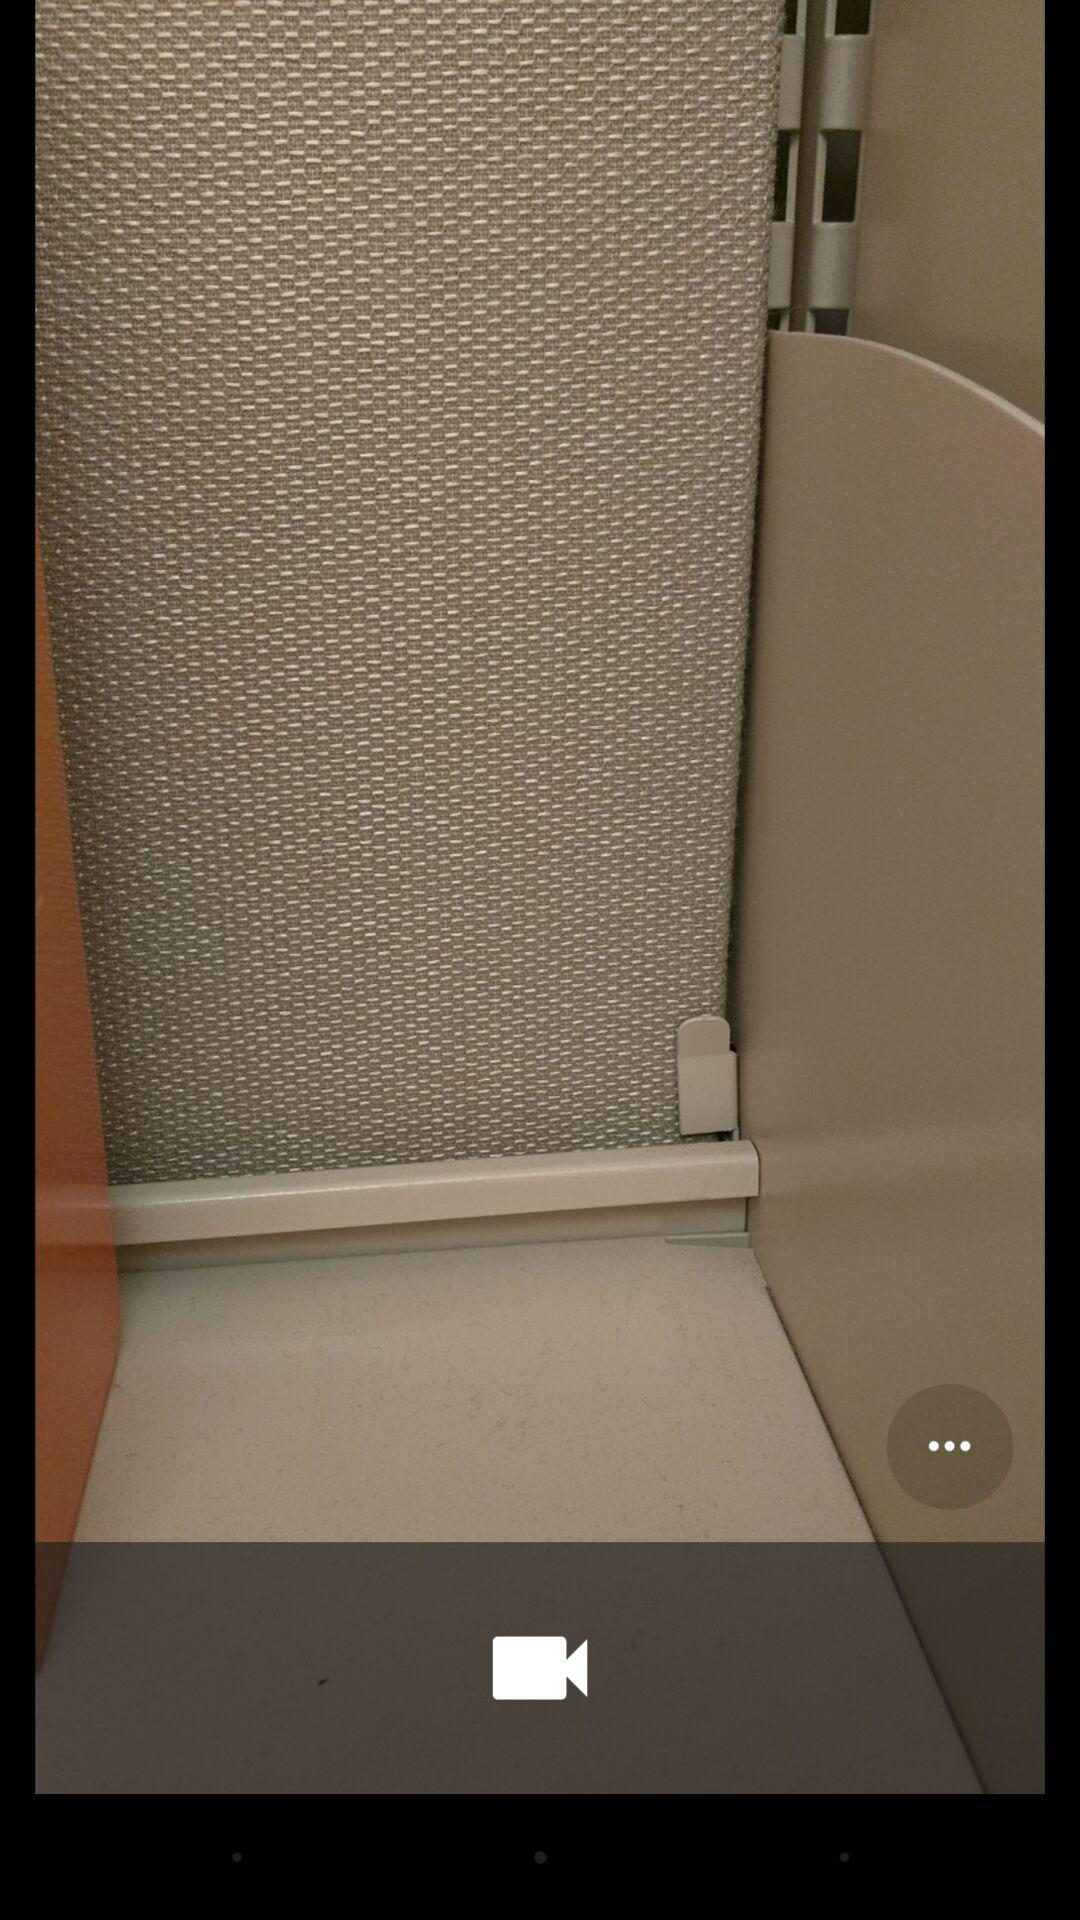How many more dots are there than videocams?
Answer the question using a single word or phrase. 2 